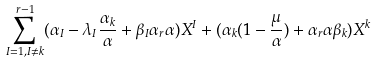Convert formula to latex. <formula><loc_0><loc_0><loc_500><loc_500>\sum ^ { r - 1 } _ { I = 1 , I \not = k } ( \alpha _ { I } - \lambda _ { I } \frac { \alpha _ { k } } { \alpha } + \beta _ { I } \alpha _ { r } \alpha ) X ^ { I } + ( \alpha _ { k } ( 1 - \frac { \mu } { \alpha } ) + \alpha _ { r } \alpha \beta _ { k } ) X ^ { k }</formula> 